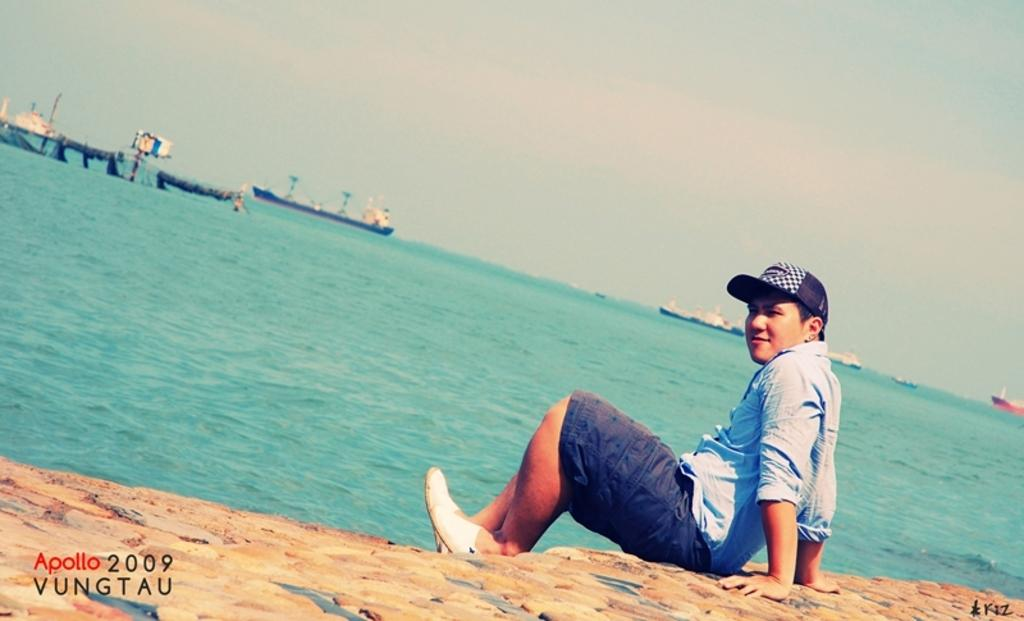What is the man in the image doing? The man is sitting in the image. What type of clothing is the man wearing? The man is wearing a shirt, shorts, and a cap. What can be seen in the water in the image? There are boats in the water. What is visible at the top of the image? The sky is visible at the top of the image. Can you tell me how many hens are present in the image? There are no hens present in the image. What type of request is the man making in the image? There is no indication of a request being made in the image. 